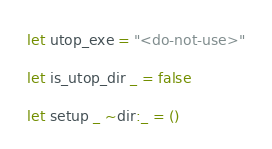Convert code to text. <code><loc_0><loc_0><loc_500><loc_500><_OCaml_>let utop_exe = "<do-not-use>"

let is_utop_dir _ = false

let setup _ ~dir:_ = ()
</code> 